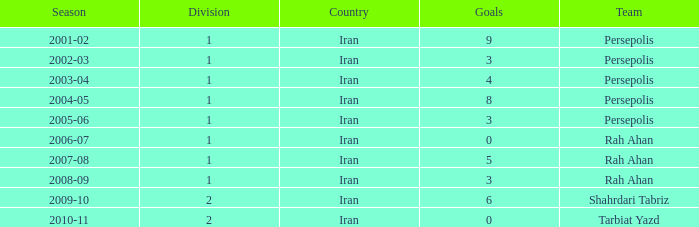What is the sum of Goals, when Season is "2005-06", and when Division is less than 1? None. Would you mind parsing the complete table? {'header': ['Season', 'Division', 'Country', 'Goals', 'Team'], 'rows': [['2001-02', '1', 'Iran', '9', 'Persepolis'], ['2002-03', '1', 'Iran', '3', 'Persepolis'], ['2003-04', '1', 'Iran', '4', 'Persepolis'], ['2004-05', '1', 'Iran', '8', 'Persepolis'], ['2005-06', '1', 'Iran', '3', 'Persepolis'], ['2006-07', '1', 'Iran', '0', 'Rah Ahan'], ['2007-08', '1', 'Iran', '5', 'Rah Ahan'], ['2008-09', '1', 'Iran', '3', 'Rah Ahan'], ['2009-10', '2', 'Iran', '6', 'Shahrdari Tabriz'], ['2010-11', '2', 'Iran', '0', 'Tarbiat Yazd']]} 